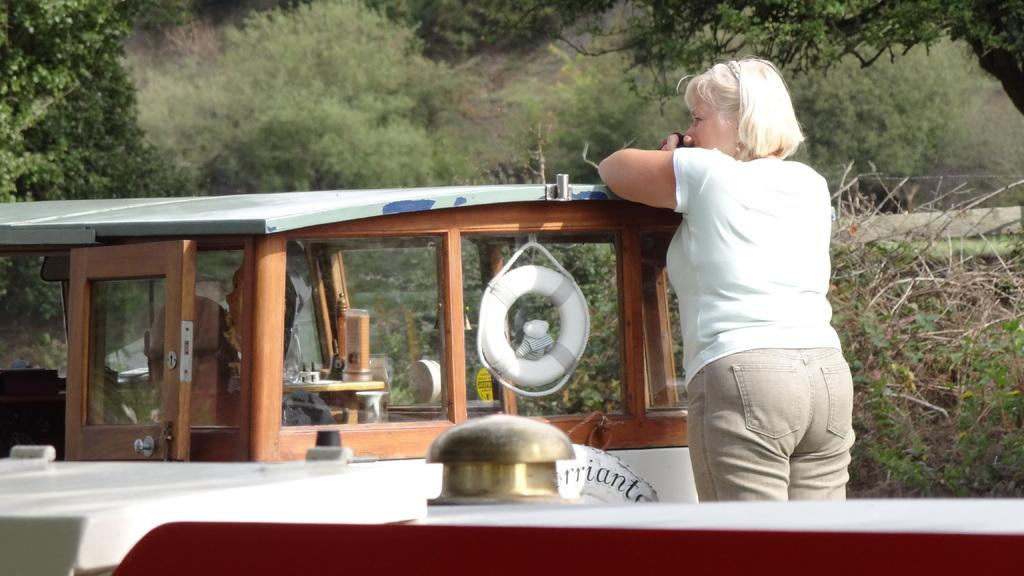What is the woman in the image standing on? The woman is standing on a ship in the image. What object can be seen in the image that resembles a tube? There is a tube in the image. What type of door is present in the image? There is a wooden door in the image. What can be seen behind the wooden door in the image? Trees are visible behind the wooden door. What type of fiction is the woman reading on the ship in the image? There is no indication in the image that the woman is reading any fiction, as the facts provided do not mention any books or reading material. 